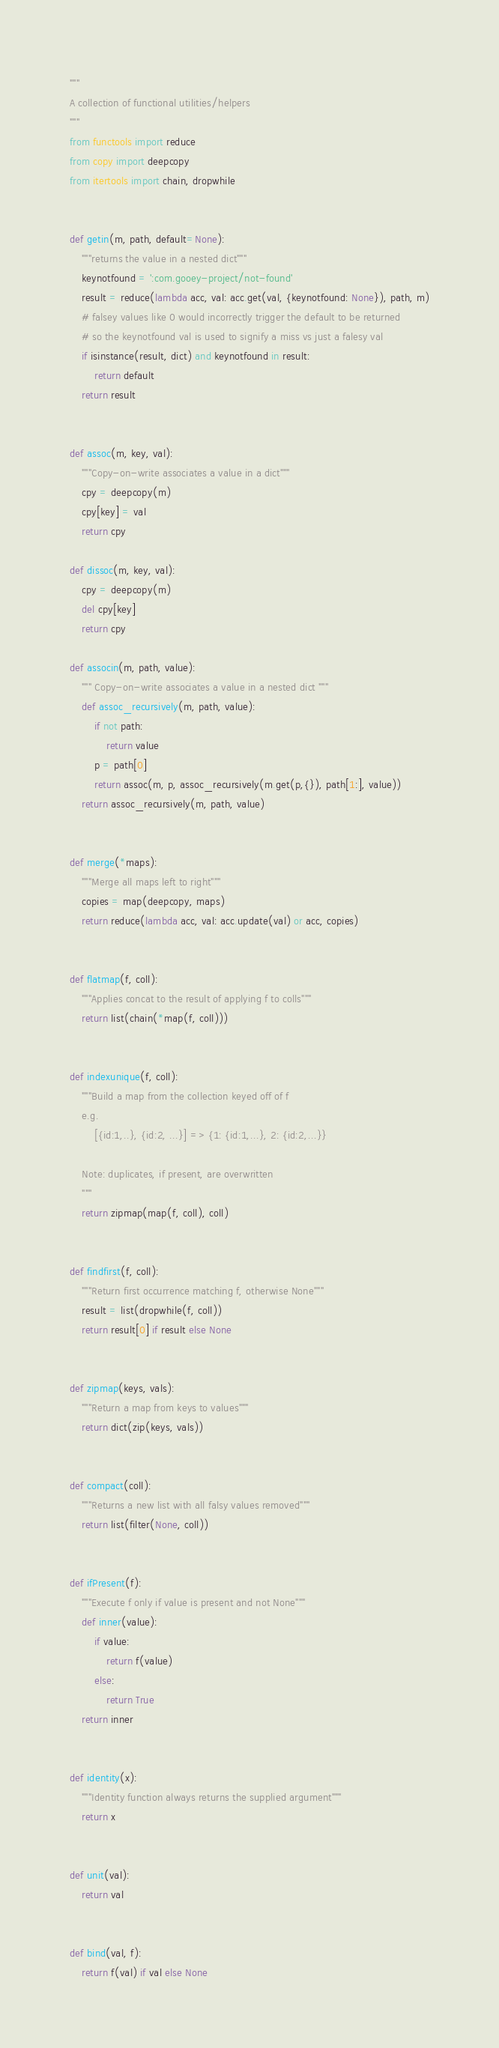Convert code to text. <code><loc_0><loc_0><loc_500><loc_500><_Python_>"""
A collection of functional utilities/helpers
"""
from functools import reduce
from copy import deepcopy
from itertools import chain, dropwhile


def getin(m, path, default=None):
    """returns the value in a nested dict"""
    keynotfound = ':com.gooey-project/not-found'
    result = reduce(lambda acc, val: acc.get(val, {keynotfound: None}), path, m)
    # falsey values like 0 would incorrectly trigger the default to be returned
    # so the keynotfound val is used to signify a miss vs just a falesy val
    if isinstance(result, dict) and keynotfound in result:
        return default
    return result


def assoc(m, key, val):
    """Copy-on-write associates a value in a dict"""
    cpy = deepcopy(m)
    cpy[key] = val
    return cpy

def dissoc(m, key, val):
    cpy = deepcopy(m)
    del cpy[key]
    return cpy

def associn(m, path, value):
    """ Copy-on-write associates a value in a nested dict """
    def assoc_recursively(m, path, value):
        if not path:
            return value
        p = path[0]
        return assoc(m, p, assoc_recursively(m.get(p,{}), path[1:], value))
    return assoc_recursively(m, path, value)


def merge(*maps):
    """Merge all maps left to right"""
    copies = map(deepcopy, maps)
    return reduce(lambda acc, val: acc.update(val) or acc, copies)


def flatmap(f, coll):
    """Applies concat to the result of applying f to colls"""
    return list(chain(*map(f, coll)))


def indexunique(f, coll):
    """Build a map from the collection keyed off of f
    e.g.
        [{id:1,..}, {id:2, ...}] => {1: {id:1,...}, 2: {id:2,...}}

    Note: duplicates, if present, are overwritten
    """
    return zipmap(map(f, coll), coll)


def findfirst(f, coll):
    """Return first occurrence matching f, otherwise None"""
    result = list(dropwhile(f, coll))
    return result[0] if result else None


def zipmap(keys, vals):
    """Return a map from keys to values"""
    return dict(zip(keys, vals))


def compact(coll):
    """Returns a new list with all falsy values removed"""
    return list(filter(None, coll))


def ifPresent(f):
    """Execute f only if value is present and not None"""
    def inner(value):
        if value:
            return f(value)
        else:
            return True
    return inner


def identity(x):
    """Identity function always returns the supplied argument"""
    return x


def unit(val):
    return val


def bind(val, f):
    return f(val) if val else None
</code> 